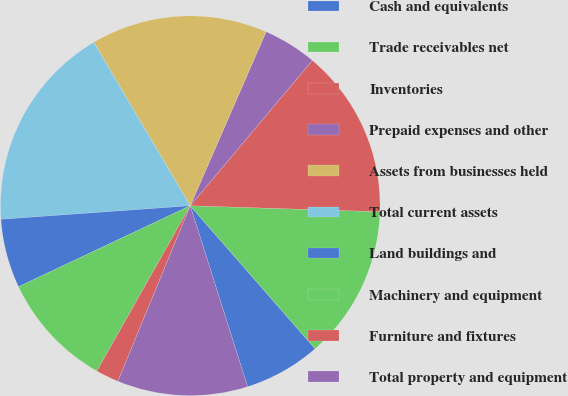Convert chart to OTSL. <chart><loc_0><loc_0><loc_500><loc_500><pie_chart><fcel>Cash and equivalents<fcel>Trade receivables net<fcel>Inventories<fcel>Prepaid expenses and other<fcel>Assets from businesses held<fcel>Total current assets<fcel>Land buildings and<fcel>Machinery and equipment<fcel>Furniture and fixtures<fcel>Total property and equipment<nl><fcel>6.54%<fcel>13.07%<fcel>14.38%<fcel>4.58%<fcel>15.03%<fcel>17.65%<fcel>5.88%<fcel>9.8%<fcel>1.96%<fcel>11.11%<nl></chart> 